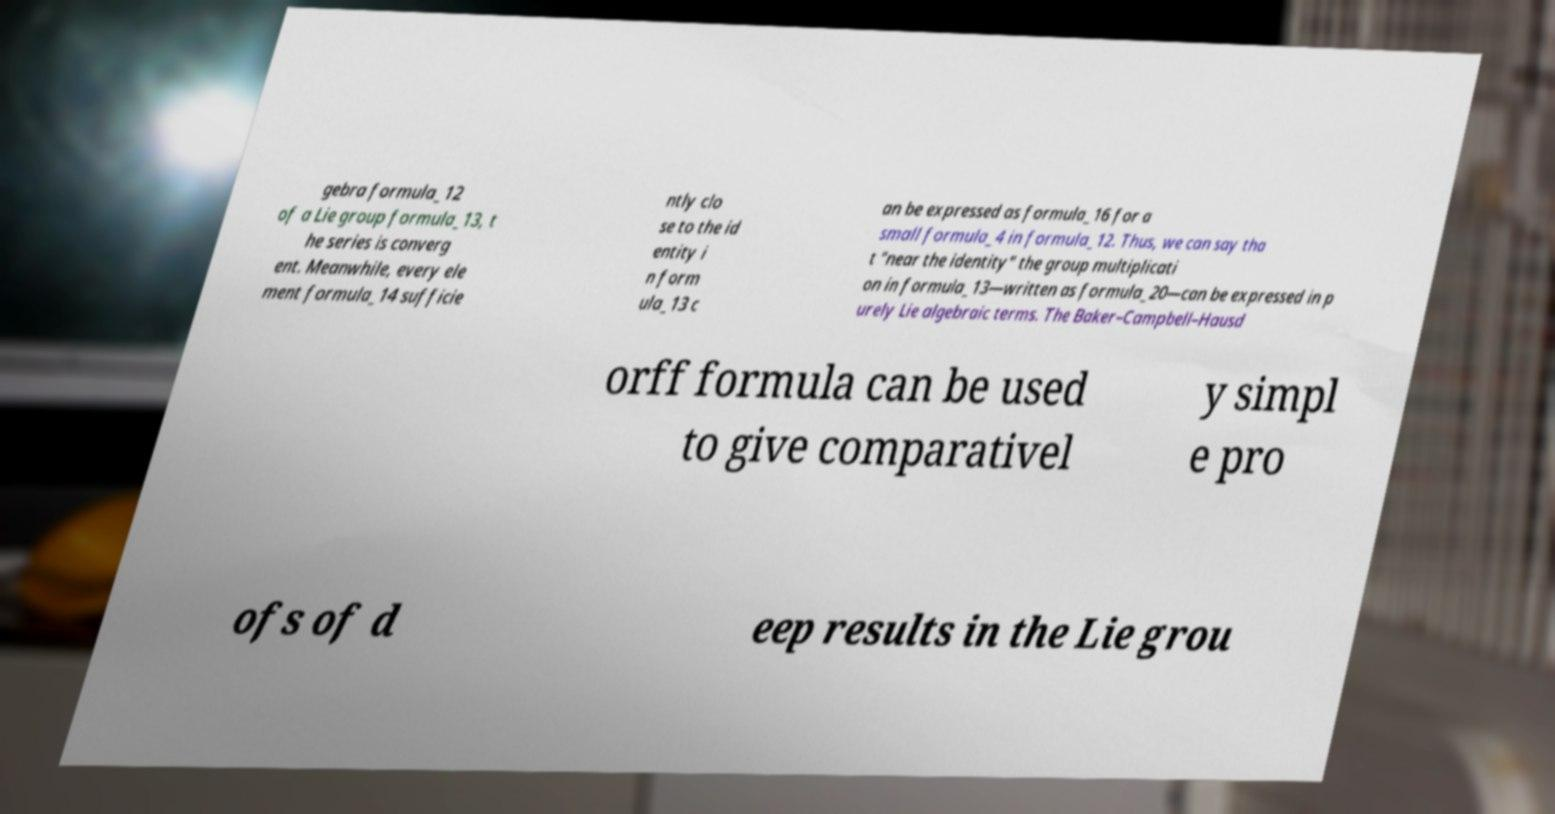Could you extract and type out the text from this image? gebra formula_12 of a Lie group formula_13, t he series is converg ent. Meanwhile, every ele ment formula_14 sufficie ntly clo se to the id entity i n form ula_13 c an be expressed as formula_16 for a small formula_4 in formula_12. Thus, we can say tha t "near the identity" the group multiplicati on in formula_13—written as formula_20—can be expressed in p urely Lie algebraic terms. The Baker–Campbell–Hausd orff formula can be used to give comparativel y simpl e pro ofs of d eep results in the Lie grou 